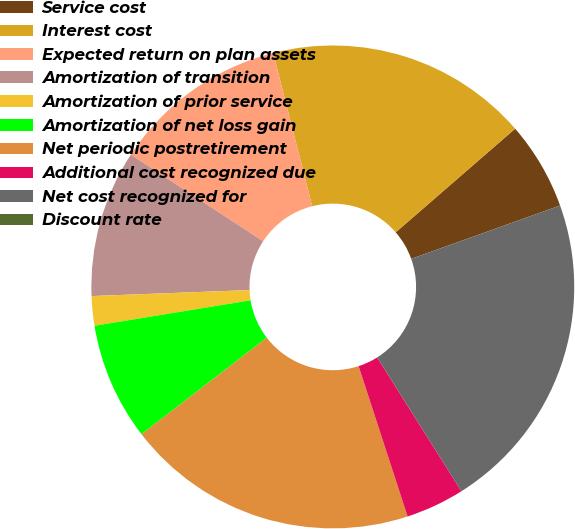Convert chart. <chart><loc_0><loc_0><loc_500><loc_500><pie_chart><fcel>Service cost<fcel>Interest cost<fcel>Expected return on plan assets<fcel>Amortization of transition<fcel>Amortization of prior service<fcel>Amortization of net loss gain<fcel>Net periodic postretirement<fcel>Additional cost recognized due<fcel>Net cost recognized for<fcel>Discount rate<nl><fcel>5.9%<fcel>17.6%<fcel>11.8%<fcel>9.83%<fcel>1.97%<fcel>7.87%<fcel>19.57%<fcel>3.93%<fcel>21.53%<fcel>0.0%<nl></chart> 